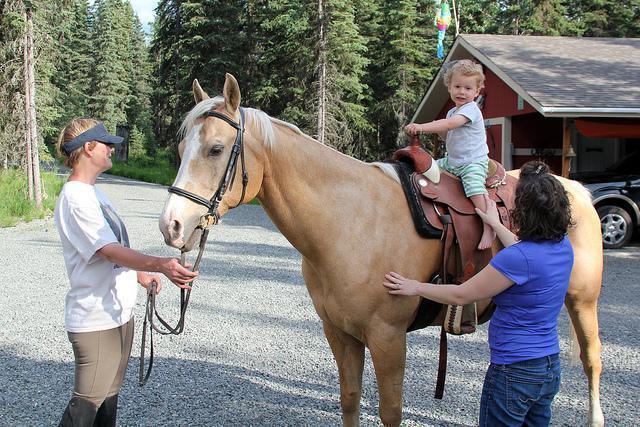Which one is probably the most proficient rider?
Indicate the correct response and explain using: 'Answer: answer
Rationale: rationale.'
Options: Striped pants, tan pants, none, blue pants. Answer: tan pants.
Rationale: The one in the beige is dressed like a rider and is holding the reins which means she probably owns the horse. 